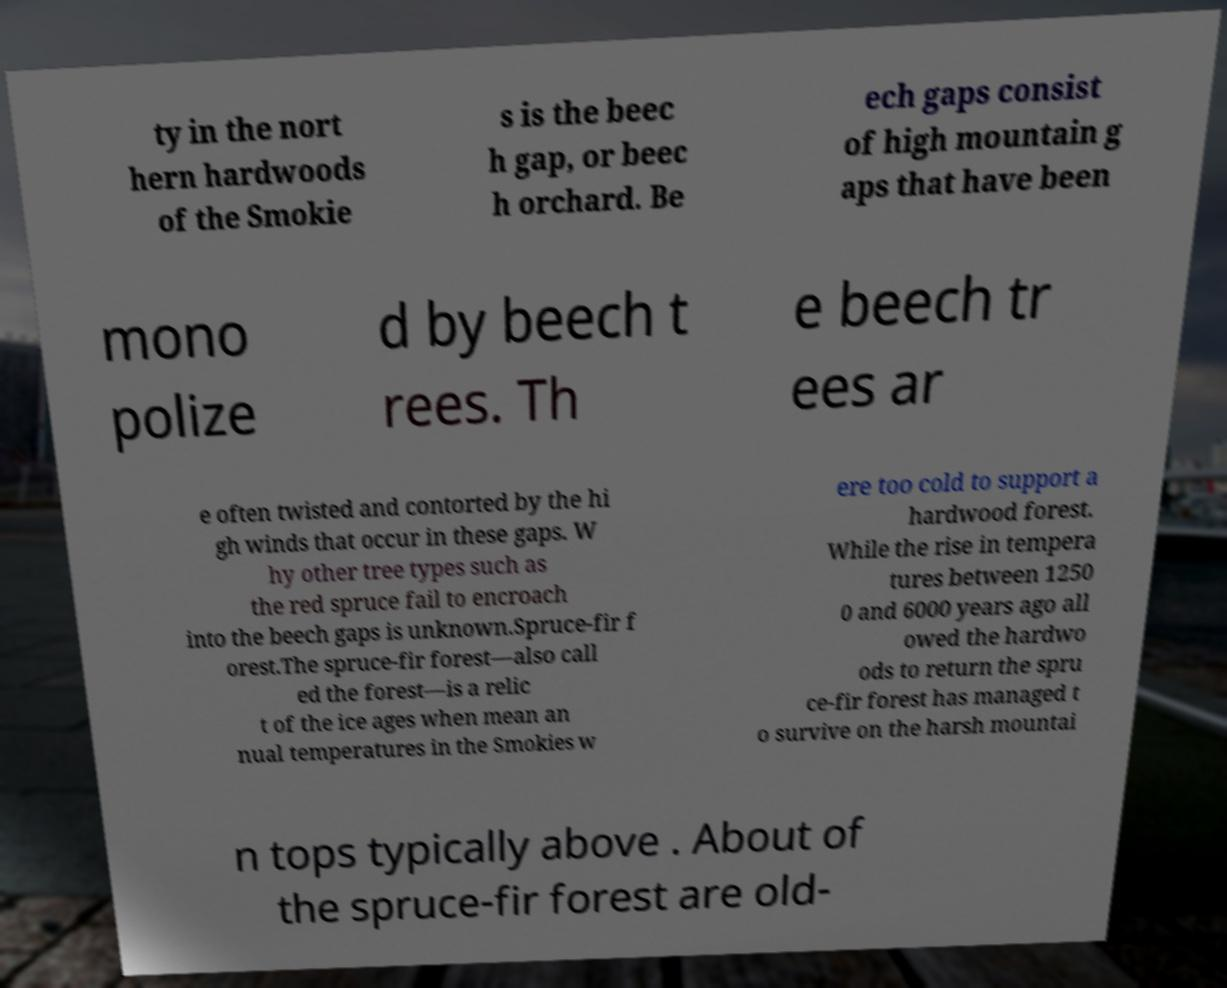Please identify and transcribe the text found in this image. ty in the nort hern hardwoods of the Smokie s is the beec h gap, or beec h orchard. Be ech gaps consist of high mountain g aps that have been mono polize d by beech t rees. Th e beech tr ees ar e often twisted and contorted by the hi gh winds that occur in these gaps. W hy other tree types such as the red spruce fail to encroach into the beech gaps is unknown.Spruce-fir f orest.The spruce-fir forest—also call ed the forest—is a relic t of the ice ages when mean an nual temperatures in the Smokies w ere too cold to support a hardwood forest. While the rise in tempera tures between 1250 0 and 6000 years ago all owed the hardwo ods to return the spru ce-fir forest has managed t o survive on the harsh mountai n tops typically above . About of the spruce-fir forest are old- 